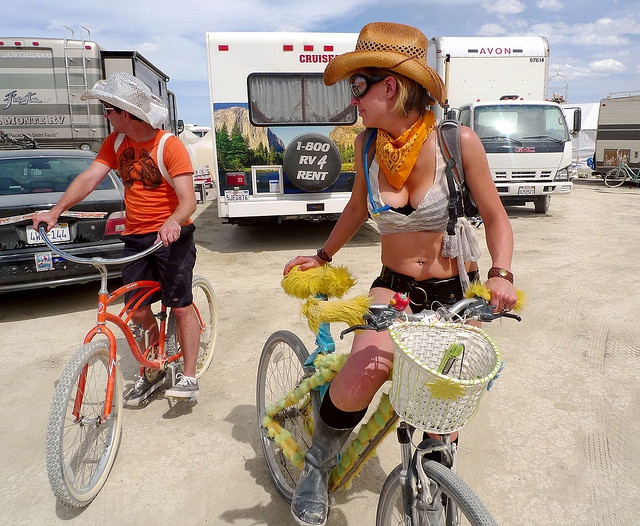Describe the objects in this image and their specific colors. I can see people in lavender, brown, black, and maroon tones, bicycle in lavender, darkgray, gray, tan, and lightgray tones, bus in lavender, lightgray, darkgray, black, and gray tones, people in lavender, black, brown, salmon, and maroon tones, and bicycle in lavender, darkgray, tan, and lightgray tones in this image. 